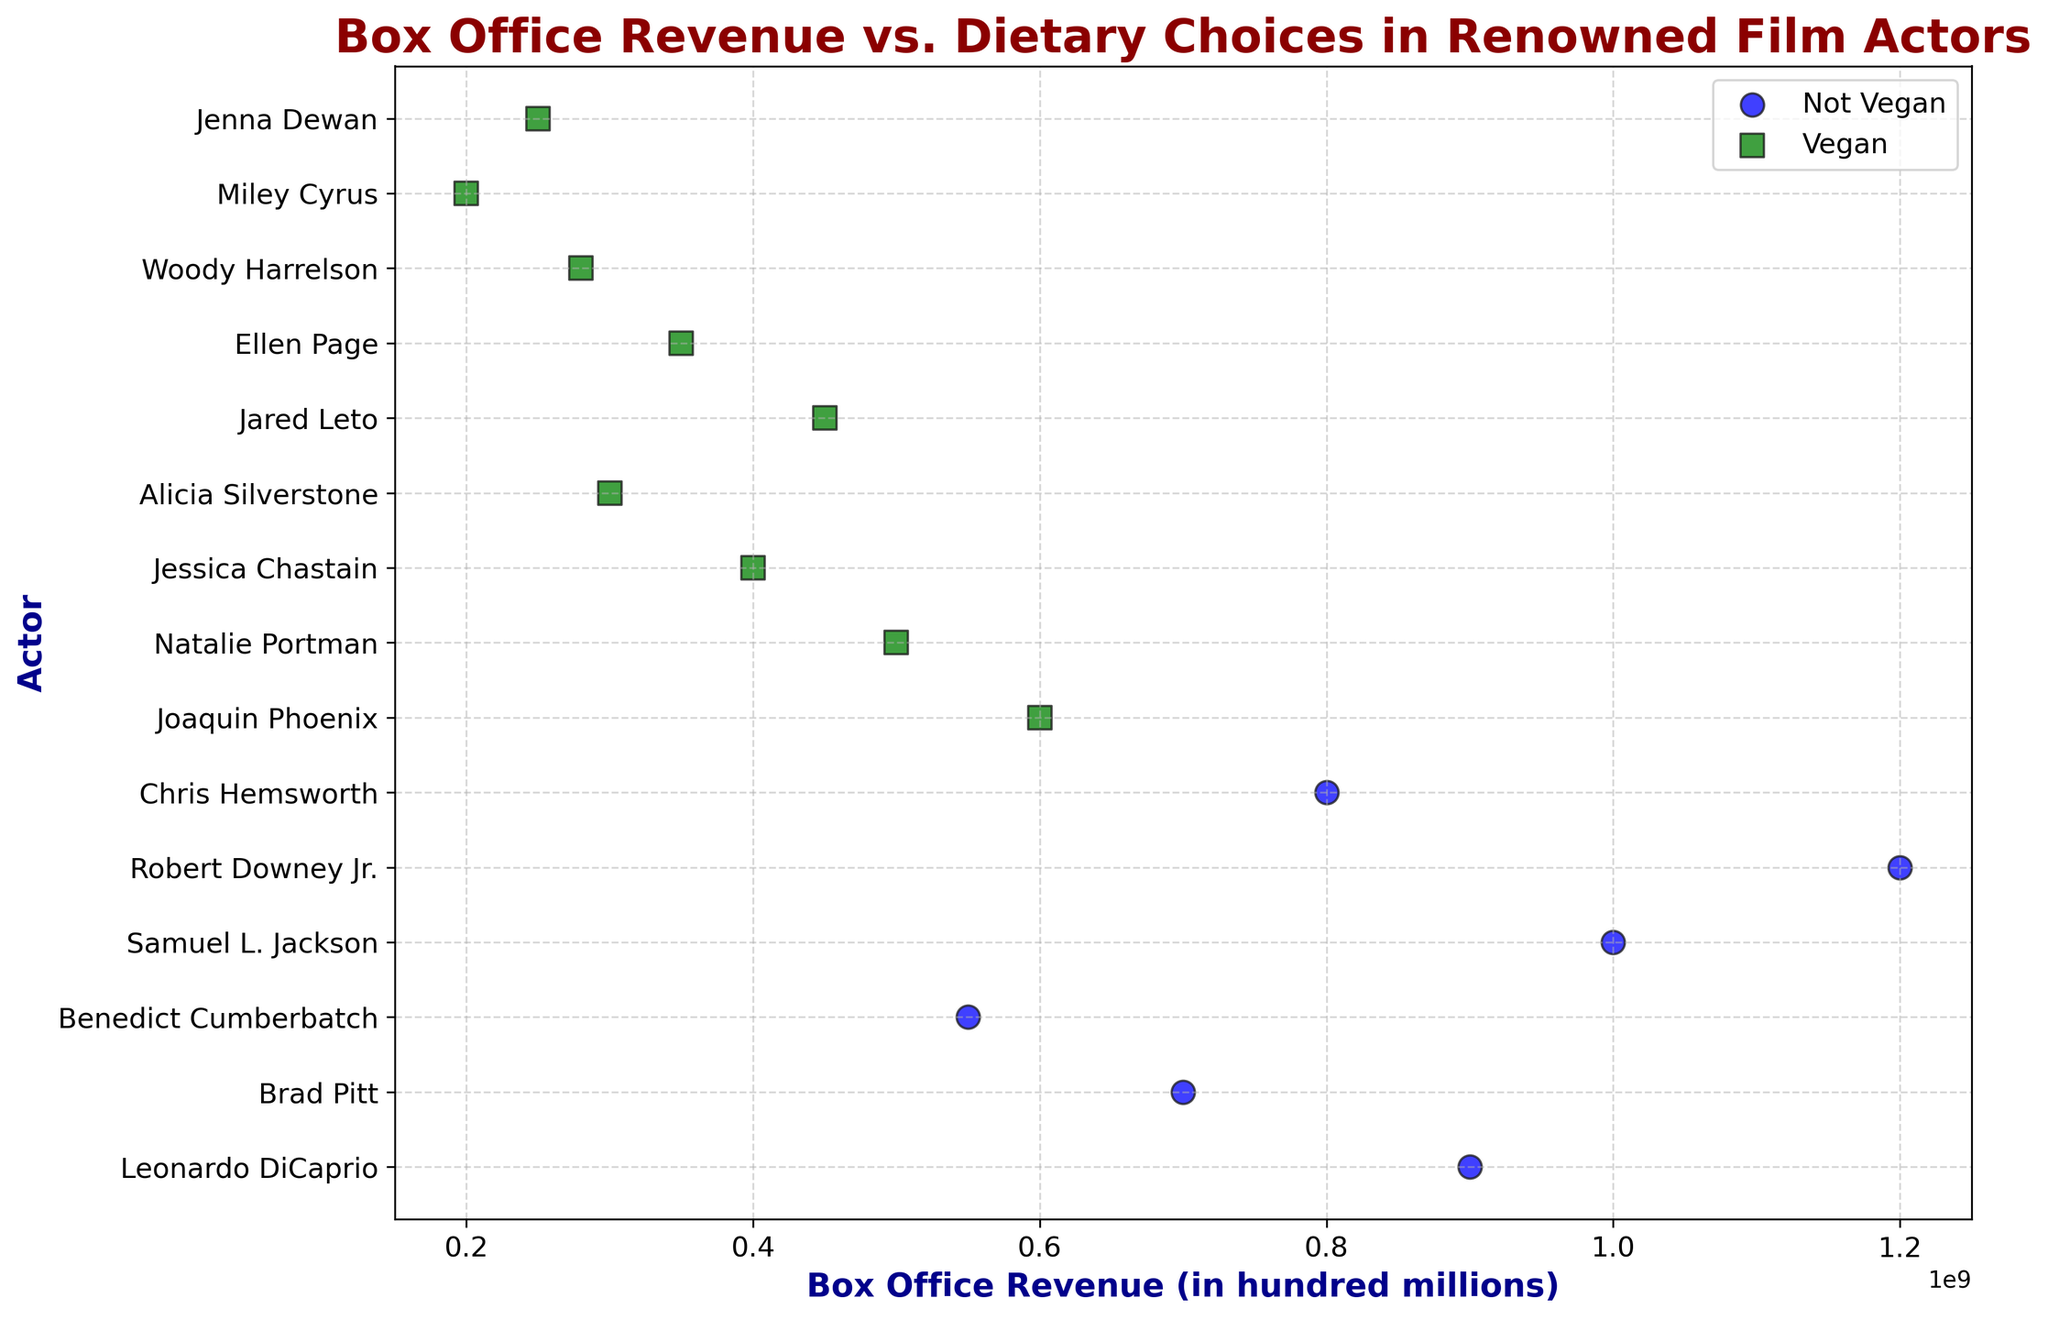What's the total box office revenue generated by vegan actors? Sum the box office revenue values for actors classified as vegan. Joaquin Phoenix (600M), Natalie Portman (500M), Jessica Chastain (400M), Alicia Silverstone (300M), Jared Leto (450M), Ellen Page (350M), Woody Harrelson (280M), Miley Cyrus (200M), Jenna Dewan (250M). Total revenue = 600 + 500 + 400 + 300 + 450 + 350 + 280 + 200 + 250 = 3,330 million.
Answer: 3,330 million Which actor has the highest box office revenue and what's their dietary choice? Identify the actor with the highest box office revenue. The highest value is 1,200 million, which corresponds to Robert Downey Jr., who is not vegan.
Answer: Robert Downey Jr., Not Vegan How many actors in the dataset are vegan? Count the number of actors whose dietary choices are indicated as vegan. The vegan actors are: Joaquin Phoenix, Natalie Portman, Jessica Chastain, Alicia Silverstone, Jared Leto, Ellen Page, Woody Harrelson, Miley Cyrus, and Jenna Dewan. There are 9 vegan actors.
Answer: 9 Compare the average box office revenue of vegan actors to non-vegan actors. Which group has a higher average revenue? Calculate the average revenue for both groups. Vegan actors' total revenue = 3,330 million, number of vegan actors = 9, average revenue = 3,330 / 9 = 370 million. Non-vegan actors' total revenue = Leonardo DiCaprio (900M) + Brad Pitt (700M) + Benedict Cumberbatch (550M) + Samuel L. Jackson (1,000M) + Robert Downey Jr. (1,200M) + Chris Hemsworth (800M) = 5,150 million, number of non-vegan actors = 6, average revenue = 5,150 / 6 = 858.3 million. Non-vegan actors have a higher average revenue.
Answer: Non-Vegan Which non-vegan actor has the least box office revenue and what is the amount? Identify the non-vegan actor with the smallest box office revenue. Benedict Cumberbatch has the least revenue among non-vegans with 550 million.
Answer: Benedict Cumberbatch, 550 million What's the combined box office revenue of the top 3 earners regardless of dietary choice? Identify the top 3 actors by box office revenue and sum their revenues. Robert Downey Jr. (1,200M), Samuel L. Jackson (1,000M), and Leonardo DiCaprio (900M). Combined revenue = 1,200 + 1,000 + 900 = 3,100 million.
Answer: 3,100 million What's the median box office revenue for vegan actors? To find the median, first order the revenues of vegan actors: (200, 250, 280, 300, 350, 400, 450, 500, 600). The median is the middle value which is 350 million.
Answer: 350 million 